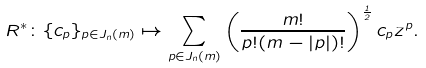Convert formula to latex. <formula><loc_0><loc_0><loc_500><loc_500>R ^ { * } \colon \{ c _ { p } \} _ { p \in J _ { n } ( m ) } \mapsto \sum _ { p \in J _ { n } ( m ) } \left ( \frac { m ! } { p ! ( m - | p | ) ! } \right ) ^ { \frac { 1 } { 2 } } c _ { p } z ^ { p } .</formula> 